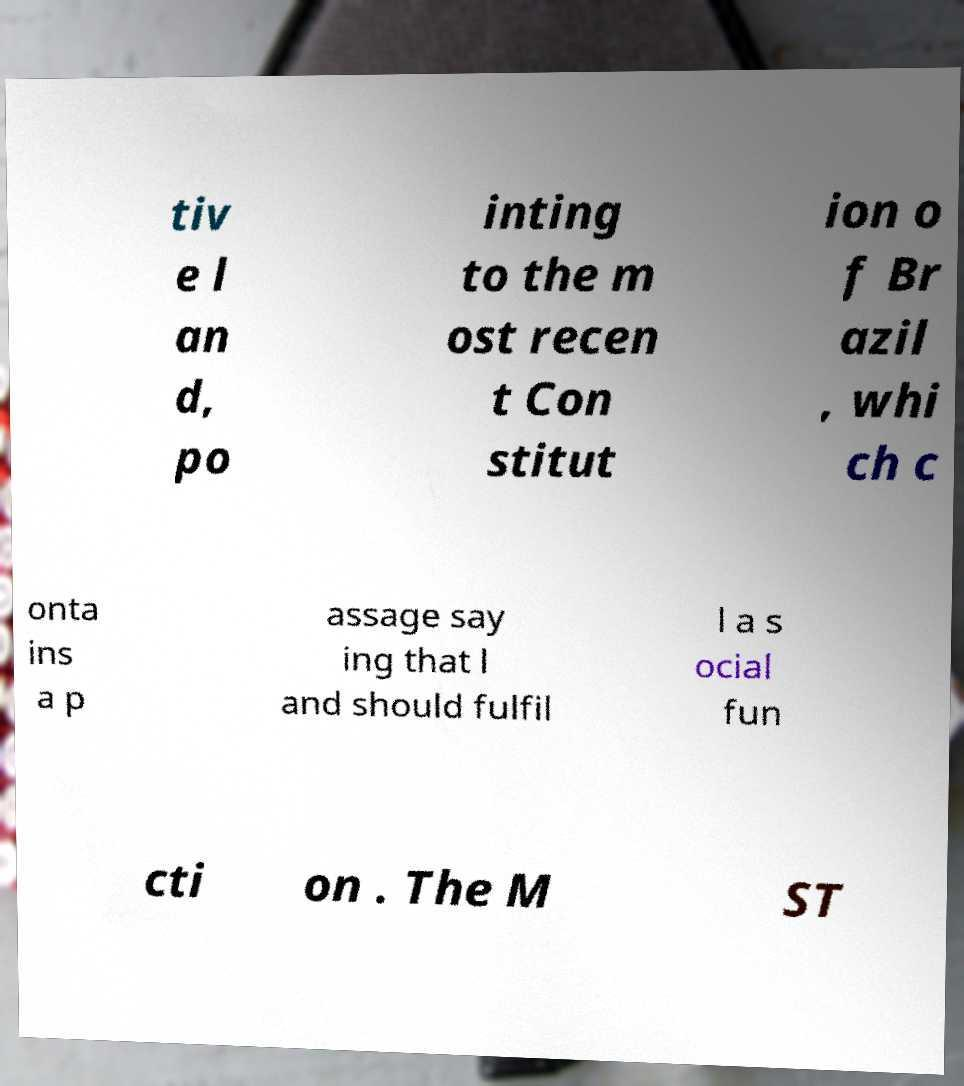Could you extract and type out the text from this image? tiv e l an d, po inting to the m ost recen t Con stitut ion o f Br azil , whi ch c onta ins a p assage say ing that l and should fulfil l a s ocial fun cti on . The M ST 